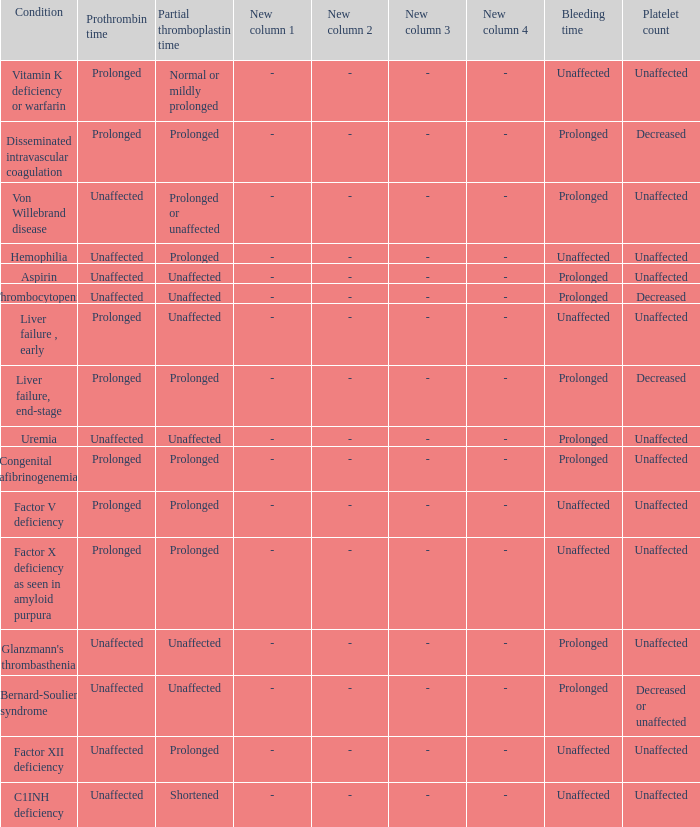Which partial thromboplastin time has a condition of liver failure , early? Unaffected. 